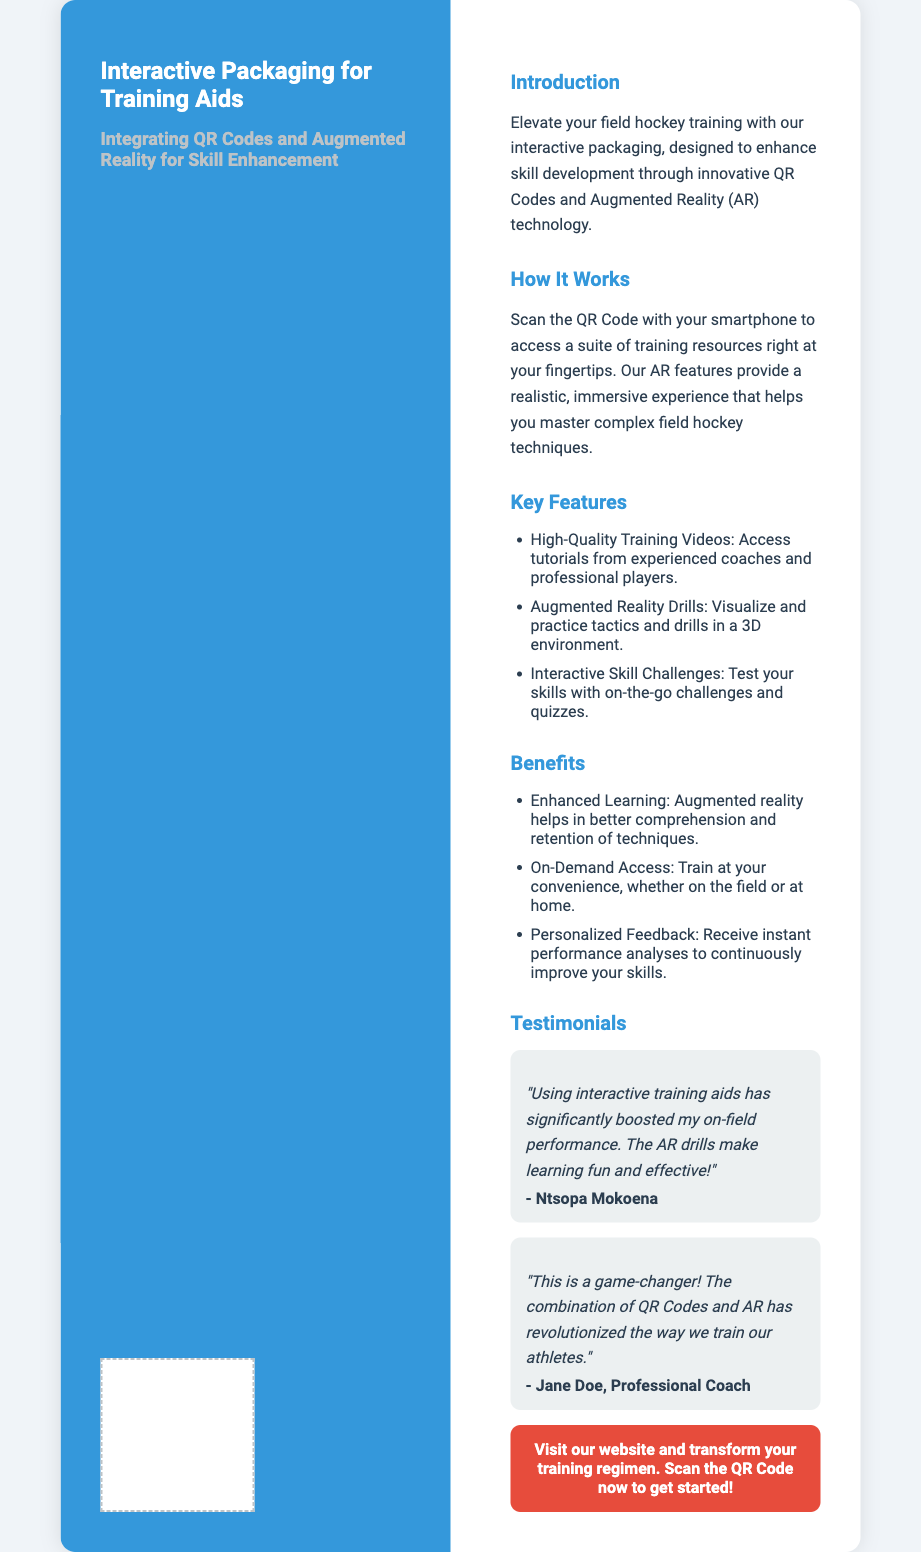What is the title of the document? The title is presented prominently at the top of the document, highlighting the main theme.
Answer: Interactive Packaging for Training Aids What technology is integrated into the training aids? The document specifies the two technologies essential for enhancing skill development.
Answer: QR Codes and Augmented Reality Who is quoted in the testimonial section? The testimonials include notable individuals related to the document's subject, including a specific name.
Answer: Ntsopa Mokoena What does the QR Code provide access to? The document states the purpose of scanning the QR Code, emphasizing the type of resources users can find.
Answer: Training resources How many key features are listed in the document? The document enumerates specific aspects about the training aids to highlight their capabilities.
Answer: Three What is one benefit of using augmented reality? The benefits section outlines advantages of the technology in training, encouraging users to engage.
Answer: Enhanced Learning What color is the left side of the package? The design details present a specific color scheme used in the packaging for differentiation.
Answer: Blue What type of feedback do users receive? The document indicates a specific form of response that athletes may get to improve their training.
Answer: Personalized Feedback 